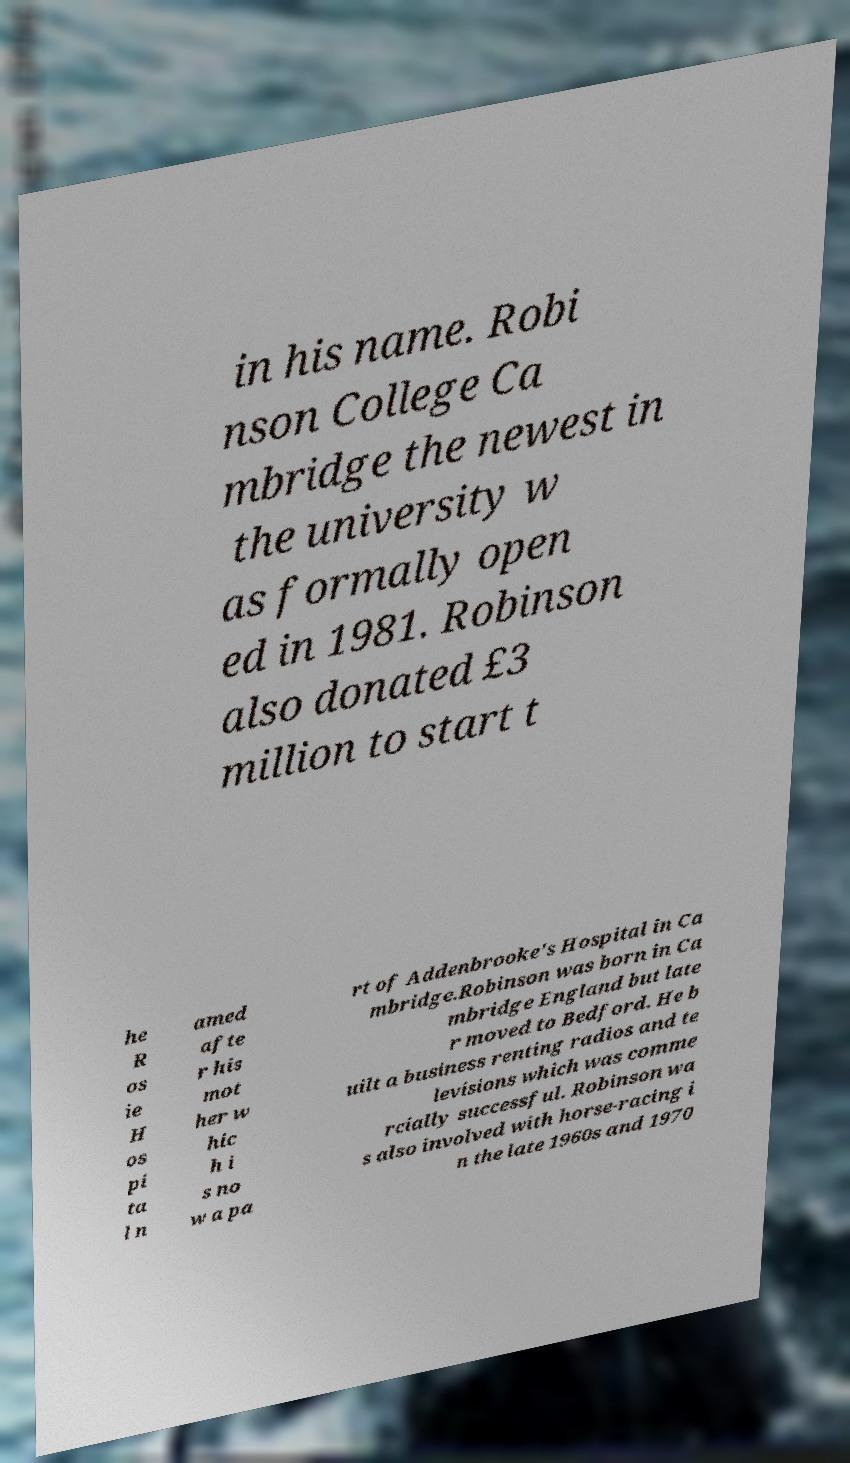For documentation purposes, I need the text within this image transcribed. Could you provide that? in his name. Robi nson College Ca mbridge the newest in the university w as formally open ed in 1981. Robinson also donated £3 million to start t he R os ie H os pi ta l n amed afte r his mot her w hic h i s no w a pa rt of Addenbrooke's Hospital in Ca mbridge.Robinson was born in Ca mbridge England but late r moved to Bedford. He b uilt a business renting radios and te levisions which was comme rcially successful. Robinson wa s also involved with horse-racing i n the late 1960s and 1970 